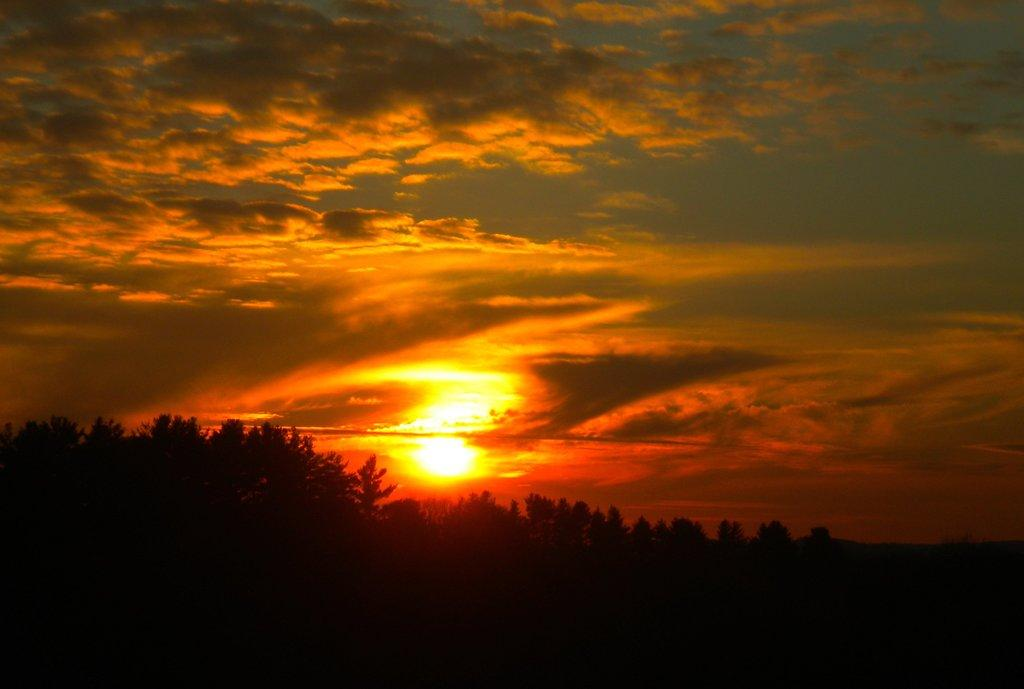What type of vegetation can be seen in the image? There are trees in the image. What celestial body is visible in the image? The sun is visible in the image. What part of the natural environment is visible in the image? The sky is visible in the image. Can you tell me how many bees are flying around the trees in the image? There are no bees visible in the image; it only features trees, the sun, and the sky. What type of egg can be seen in the image? There are no eggs present in the image. 